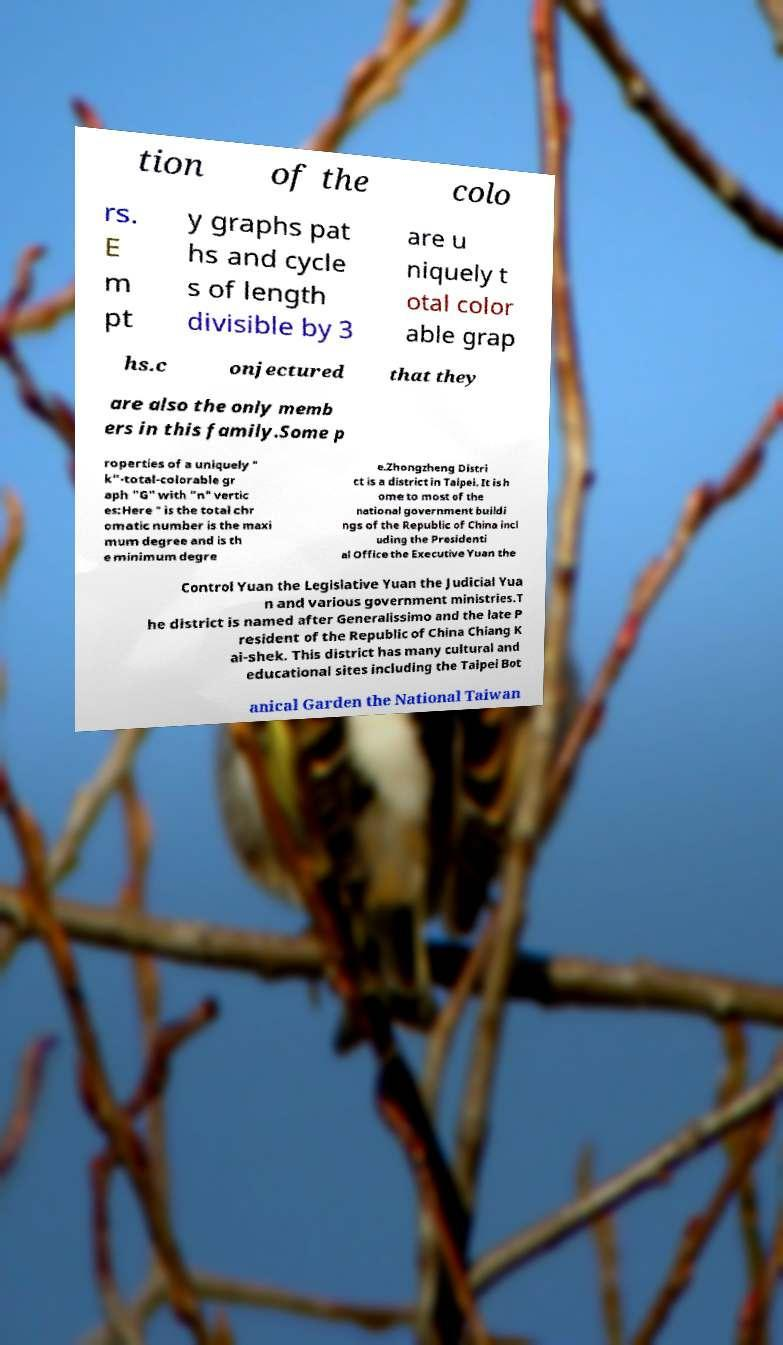Can you accurately transcribe the text from the provided image for me? tion of the colo rs. E m pt y graphs pat hs and cycle s of length divisible by 3 are u niquely t otal color able grap hs.c onjectured that they are also the only memb ers in this family.Some p roperties of a uniquely " k"-total-colorable gr aph "G" with "n" vertic es:Here ″ is the total chr omatic number is the maxi mum degree and is th e minimum degre e.Zhongzheng Distri ct is a district in Taipei. It is h ome to most of the national government buildi ngs of the Republic of China incl uding the Presidenti al Office the Executive Yuan the Control Yuan the Legislative Yuan the Judicial Yua n and various government ministries.T he district is named after Generalissimo and the late P resident of the Republic of China Chiang K ai-shek. This district has many cultural and educational sites including the Taipei Bot anical Garden the National Taiwan 